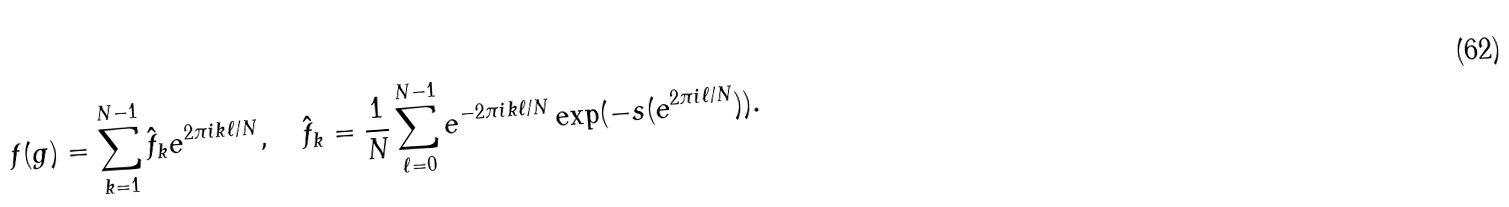Convert formula to latex. <formula><loc_0><loc_0><loc_500><loc_500>f ( g ) = \sum _ { k = 1 } ^ { N - 1 } \hat { f } _ { k } e ^ { 2 \pi i k \ell / N } , \quad \hat { f } _ { k } = \frac { 1 } { N } \sum _ { \ell = 0 } ^ { N - 1 } e ^ { - 2 \pi i k \ell / N } \exp ( - s ( e ^ { 2 \pi i \ell / N } ) ) .</formula> 